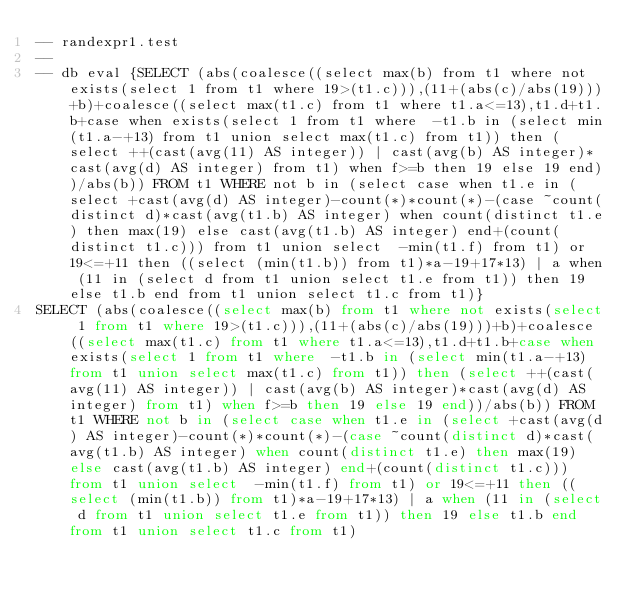Convert code to text. <code><loc_0><loc_0><loc_500><loc_500><_SQL_>-- randexpr1.test
-- 
-- db eval {SELECT (abs(coalesce((select max(b) from t1 where not exists(select 1 from t1 where 19>(t1.c))),(11+(abs(c)/abs(19)))+b)+coalesce((select max(t1.c) from t1 where t1.a<=13),t1.d+t1.b+case when exists(select 1 from t1 where  -t1.b in (select min(t1.a-+13) from t1 union select max(t1.c) from t1)) then (select ++(cast(avg(11) AS integer)) | cast(avg(b) AS integer)*cast(avg(d) AS integer) from t1) when f>=b then 19 else 19 end))/abs(b)) FROM t1 WHERE not b in (select case when t1.e in (select +cast(avg(d) AS integer)-count(*)*count(*)-(case ~count(distinct d)*cast(avg(t1.b) AS integer) when count(distinct t1.e) then max(19) else cast(avg(t1.b) AS integer) end+(count(distinct t1.c))) from t1 union select  -min(t1.f) from t1) or 19<=+11 then ((select (min(t1.b)) from t1)*a-19+17*13) | a when (11 in (select d from t1 union select t1.e from t1)) then 19 else t1.b end from t1 union select t1.c from t1)}
SELECT (abs(coalesce((select max(b) from t1 where not exists(select 1 from t1 where 19>(t1.c))),(11+(abs(c)/abs(19)))+b)+coalesce((select max(t1.c) from t1 where t1.a<=13),t1.d+t1.b+case when exists(select 1 from t1 where  -t1.b in (select min(t1.a-+13) from t1 union select max(t1.c) from t1)) then (select ++(cast(avg(11) AS integer)) | cast(avg(b) AS integer)*cast(avg(d) AS integer) from t1) when f>=b then 19 else 19 end))/abs(b)) FROM t1 WHERE not b in (select case when t1.e in (select +cast(avg(d) AS integer)-count(*)*count(*)-(case ~count(distinct d)*cast(avg(t1.b) AS integer) when count(distinct t1.e) then max(19) else cast(avg(t1.b) AS integer) end+(count(distinct t1.c))) from t1 union select  -min(t1.f) from t1) or 19<=+11 then ((select (min(t1.b)) from t1)*a-19+17*13) | a when (11 in (select d from t1 union select t1.e from t1)) then 19 else t1.b end from t1 union select t1.c from t1)</code> 